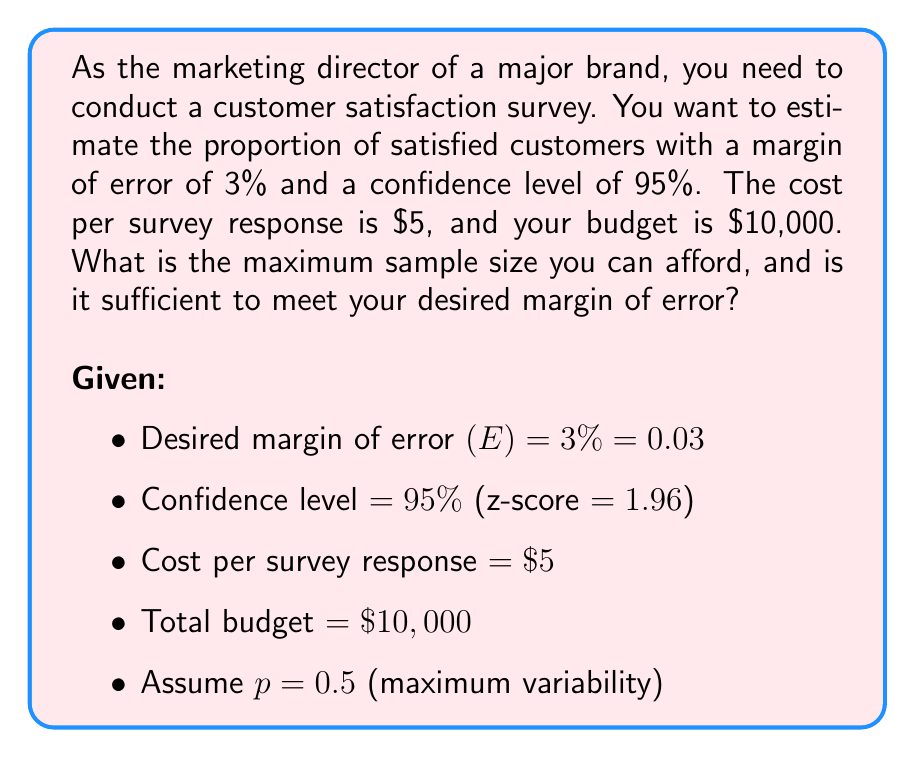Could you help me with this problem? 1. Calculate the maximum affordable sample size:
   $$n_{max} = \frac{\text{Total budget}}{\text{Cost per response}} = \frac{\$10,000}{\$5} = 2,000$$

2. Calculate the required sample size for the desired margin of error:
   $$n = \frac{z^2 p(1-p)}{E^2}$$
   where:
   z = 1.96 (95% confidence level)
   p = 0.5 (assumed maximum variability)
   E = 0.03 (desired margin of error)

   $$n = \frac{1.96^2 \cdot 0.5(1-0.5)}{0.03^2} = \frac{3.8416 \cdot 0.25}{0.0009} = 1,067.11$$

   Round up to the nearest whole number: n = 1,068

3. Compare the maximum affordable sample size to the required sample size:
   2,000 > 1,068

4. Conclusion: The maximum affordable sample size (2,000) is greater than the required sample size (1,068) to achieve the desired margin of error.
Answer: Maximum affordable sample size: 2,000; Required sample size: 1,068; Sufficient budget: Yes 